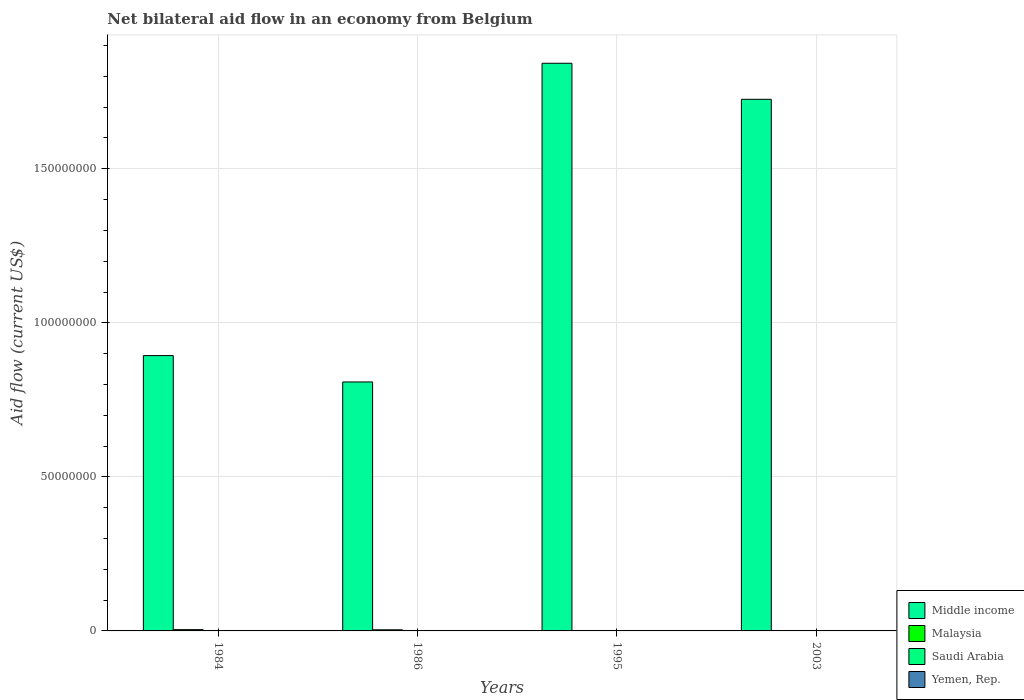Are the number of bars per tick equal to the number of legend labels?
Make the answer very short. No. Are the number of bars on each tick of the X-axis equal?
Provide a succinct answer. No. How many bars are there on the 3rd tick from the right?
Your answer should be very brief. 4. What is the label of the 3rd group of bars from the left?
Keep it short and to the point. 1995. Across all years, what is the minimum net bilateral aid flow in Middle income?
Ensure brevity in your answer.  8.08e+07. What is the total net bilateral aid flow in Saudi Arabia in the graph?
Provide a succinct answer. 7.00e+04. What is the difference between the net bilateral aid flow in Yemen, Rep. in 1984 and that in 2003?
Provide a succinct answer. -3.00e+04. What is the difference between the net bilateral aid flow in Middle income in 2003 and the net bilateral aid flow in Yemen, Rep. in 1995?
Make the answer very short. 1.73e+08. What is the average net bilateral aid flow in Saudi Arabia per year?
Your answer should be very brief. 1.75e+04. In the year 1984, what is the difference between the net bilateral aid flow in Saudi Arabia and net bilateral aid flow in Malaysia?
Offer a very short reply. -3.70e+05. In how many years, is the net bilateral aid flow in Malaysia greater than 20000000 US$?
Provide a short and direct response. 0. What is the difference between the highest and the second highest net bilateral aid flow in Saudi Arabia?
Your response must be concise. 4.00e+04. What is the difference between the highest and the lowest net bilateral aid flow in Middle income?
Ensure brevity in your answer.  1.03e+08. Is the sum of the net bilateral aid flow in Middle income in 1986 and 2003 greater than the maximum net bilateral aid flow in Yemen, Rep. across all years?
Offer a terse response. Yes. Is it the case that in every year, the sum of the net bilateral aid flow in Malaysia and net bilateral aid flow in Middle income is greater than the sum of net bilateral aid flow in Yemen, Rep. and net bilateral aid flow in Saudi Arabia?
Provide a succinct answer. Yes. How many bars are there?
Give a very brief answer. 15. Are all the bars in the graph horizontal?
Give a very brief answer. No. How many years are there in the graph?
Offer a terse response. 4. What is the difference between two consecutive major ticks on the Y-axis?
Give a very brief answer. 5.00e+07. Are the values on the major ticks of Y-axis written in scientific E-notation?
Your answer should be compact. No. Does the graph contain any zero values?
Keep it short and to the point. Yes. How many legend labels are there?
Your answer should be compact. 4. What is the title of the graph?
Your answer should be compact. Net bilateral aid flow in an economy from Belgium. What is the Aid flow (current US$) in Middle income in 1984?
Your answer should be compact. 8.94e+07. What is the Aid flow (current US$) in Malaysia in 1984?
Offer a terse response. 4.20e+05. What is the Aid flow (current US$) of Middle income in 1986?
Keep it short and to the point. 8.08e+07. What is the Aid flow (current US$) in Middle income in 1995?
Provide a short and direct response. 1.84e+08. What is the Aid flow (current US$) in Saudi Arabia in 1995?
Your response must be concise. 10000. What is the Aid flow (current US$) of Middle income in 2003?
Make the answer very short. 1.73e+08. What is the Aid flow (current US$) of Malaysia in 2003?
Give a very brief answer. 9.00e+04. What is the Aid flow (current US$) in Yemen, Rep. in 2003?
Keep it short and to the point. 1.10e+05. Across all years, what is the maximum Aid flow (current US$) in Middle income?
Give a very brief answer. 1.84e+08. Across all years, what is the maximum Aid flow (current US$) of Malaysia?
Your response must be concise. 4.20e+05. Across all years, what is the maximum Aid flow (current US$) of Saudi Arabia?
Offer a very short reply. 5.00e+04. Across all years, what is the maximum Aid flow (current US$) in Yemen, Rep.?
Offer a very short reply. 1.10e+05. Across all years, what is the minimum Aid flow (current US$) in Middle income?
Make the answer very short. 8.08e+07. Across all years, what is the minimum Aid flow (current US$) in Malaysia?
Ensure brevity in your answer.  9.00e+04. Across all years, what is the minimum Aid flow (current US$) in Saudi Arabia?
Your answer should be very brief. 0. What is the total Aid flow (current US$) of Middle income in the graph?
Give a very brief answer. 5.27e+08. What is the total Aid flow (current US$) of Malaysia in the graph?
Give a very brief answer. 9.70e+05. What is the total Aid flow (current US$) of Yemen, Rep. in the graph?
Provide a succinct answer. 2.10e+05. What is the difference between the Aid flow (current US$) of Middle income in 1984 and that in 1986?
Your answer should be very brief. 8.56e+06. What is the difference between the Aid flow (current US$) in Malaysia in 1984 and that in 1986?
Offer a terse response. 6.00e+04. What is the difference between the Aid flow (current US$) of Saudi Arabia in 1984 and that in 1986?
Your answer should be very brief. 4.00e+04. What is the difference between the Aid flow (current US$) in Yemen, Rep. in 1984 and that in 1986?
Offer a very short reply. 7.00e+04. What is the difference between the Aid flow (current US$) of Middle income in 1984 and that in 1995?
Provide a short and direct response. -9.49e+07. What is the difference between the Aid flow (current US$) in Saudi Arabia in 1984 and that in 1995?
Your response must be concise. 4.00e+04. What is the difference between the Aid flow (current US$) of Middle income in 1984 and that in 2003?
Your answer should be compact. -8.32e+07. What is the difference between the Aid flow (current US$) of Yemen, Rep. in 1984 and that in 2003?
Your response must be concise. -3.00e+04. What is the difference between the Aid flow (current US$) of Middle income in 1986 and that in 1995?
Your answer should be very brief. -1.03e+08. What is the difference between the Aid flow (current US$) of Malaysia in 1986 and that in 1995?
Keep it short and to the point. 2.60e+05. What is the difference between the Aid flow (current US$) in Saudi Arabia in 1986 and that in 1995?
Give a very brief answer. 0. What is the difference between the Aid flow (current US$) in Middle income in 1986 and that in 2003?
Make the answer very short. -9.18e+07. What is the difference between the Aid flow (current US$) of Malaysia in 1986 and that in 2003?
Offer a terse response. 2.70e+05. What is the difference between the Aid flow (current US$) of Middle income in 1995 and that in 2003?
Make the answer very short. 1.17e+07. What is the difference between the Aid flow (current US$) of Malaysia in 1995 and that in 2003?
Offer a very short reply. 10000. What is the difference between the Aid flow (current US$) of Yemen, Rep. in 1995 and that in 2003?
Provide a succinct answer. -1.00e+05. What is the difference between the Aid flow (current US$) in Middle income in 1984 and the Aid flow (current US$) in Malaysia in 1986?
Ensure brevity in your answer.  8.90e+07. What is the difference between the Aid flow (current US$) of Middle income in 1984 and the Aid flow (current US$) of Saudi Arabia in 1986?
Give a very brief answer. 8.94e+07. What is the difference between the Aid flow (current US$) of Middle income in 1984 and the Aid flow (current US$) of Yemen, Rep. in 1986?
Your answer should be very brief. 8.94e+07. What is the difference between the Aid flow (current US$) of Malaysia in 1984 and the Aid flow (current US$) of Saudi Arabia in 1986?
Give a very brief answer. 4.10e+05. What is the difference between the Aid flow (current US$) of Malaysia in 1984 and the Aid flow (current US$) of Yemen, Rep. in 1986?
Keep it short and to the point. 4.10e+05. What is the difference between the Aid flow (current US$) in Middle income in 1984 and the Aid flow (current US$) in Malaysia in 1995?
Provide a succinct answer. 8.93e+07. What is the difference between the Aid flow (current US$) in Middle income in 1984 and the Aid flow (current US$) in Saudi Arabia in 1995?
Provide a short and direct response. 8.94e+07. What is the difference between the Aid flow (current US$) in Middle income in 1984 and the Aid flow (current US$) in Yemen, Rep. in 1995?
Keep it short and to the point. 8.94e+07. What is the difference between the Aid flow (current US$) in Malaysia in 1984 and the Aid flow (current US$) in Saudi Arabia in 1995?
Your answer should be compact. 4.10e+05. What is the difference between the Aid flow (current US$) in Malaysia in 1984 and the Aid flow (current US$) in Yemen, Rep. in 1995?
Offer a terse response. 4.10e+05. What is the difference between the Aid flow (current US$) in Saudi Arabia in 1984 and the Aid flow (current US$) in Yemen, Rep. in 1995?
Offer a very short reply. 4.00e+04. What is the difference between the Aid flow (current US$) in Middle income in 1984 and the Aid flow (current US$) in Malaysia in 2003?
Ensure brevity in your answer.  8.93e+07. What is the difference between the Aid flow (current US$) of Middle income in 1984 and the Aid flow (current US$) of Yemen, Rep. in 2003?
Give a very brief answer. 8.93e+07. What is the difference between the Aid flow (current US$) of Malaysia in 1984 and the Aid flow (current US$) of Yemen, Rep. in 2003?
Ensure brevity in your answer.  3.10e+05. What is the difference between the Aid flow (current US$) of Saudi Arabia in 1984 and the Aid flow (current US$) of Yemen, Rep. in 2003?
Give a very brief answer. -6.00e+04. What is the difference between the Aid flow (current US$) of Middle income in 1986 and the Aid flow (current US$) of Malaysia in 1995?
Make the answer very short. 8.07e+07. What is the difference between the Aid flow (current US$) in Middle income in 1986 and the Aid flow (current US$) in Saudi Arabia in 1995?
Provide a short and direct response. 8.08e+07. What is the difference between the Aid flow (current US$) in Middle income in 1986 and the Aid flow (current US$) in Yemen, Rep. in 1995?
Offer a very short reply. 8.08e+07. What is the difference between the Aid flow (current US$) of Malaysia in 1986 and the Aid flow (current US$) of Saudi Arabia in 1995?
Offer a terse response. 3.50e+05. What is the difference between the Aid flow (current US$) of Malaysia in 1986 and the Aid flow (current US$) of Yemen, Rep. in 1995?
Offer a very short reply. 3.50e+05. What is the difference between the Aid flow (current US$) in Saudi Arabia in 1986 and the Aid flow (current US$) in Yemen, Rep. in 1995?
Offer a very short reply. 0. What is the difference between the Aid flow (current US$) of Middle income in 1986 and the Aid flow (current US$) of Malaysia in 2003?
Provide a short and direct response. 8.07e+07. What is the difference between the Aid flow (current US$) in Middle income in 1986 and the Aid flow (current US$) in Yemen, Rep. in 2003?
Offer a terse response. 8.07e+07. What is the difference between the Aid flow (current US$) in Malaysia in 1986 and the Aid flow (current US$) in Yemen, Rep. in 2003?
Keep it short and to the point. 2.50e+05. What is the difference between the Aid flow (current US$) in Saudi Arabia in 1986 and the Aid flow (current US$) in Yemen, Rep. in 2003?
Make the answer very short. -1.00e+05. What is the difference between the Aid flow (current US$) in Middle income in 1995 and the Aid flow (current US$) in Malaysia in 2003?
Your answer should be very brief. 1.84e+08. What is the difference between the Aid flow (current US$) of Middle income in 1995 and the Aid flow (current US$) of Yemen, Rep. in 2003?
Ensure brevity in your answer.  1.84e+08. What is the difference between the Aid flow (current US$) in Malaysia in 1995 and the Aid flow (current US$) in Yemen, Rep. in 2003?
Keep it short and to the point. -10000. What is the difference between the Aid flow (current US$) in Saudi Arabia in 1995 and the Aid flow (current US$) in Yemen, Rep. in 2003?
Your response must be concise. -1.00e+05. What is the average Aid flow (current US$) of Middle income per year?
Your response must be concise. 1.32e+08. What is the average Aid flow (current US$) in Malaysia per year?
Your answer should be very brief. 2.42e+05. What is the average Aid flow (current US$) of Saudi Arabia per year?
Ensure brevity in your answer.  1.75e+04. What is the average Aid flow (current US$) of Yemen, Rep. per year?
Make the answer very short. 5.25e+04. In the year 1984, what is the difference between the Aid flow (current US$) in Middle income and Aid flow (current US$) in Malaysia?
Provide a short and direct response. 8.90e+07. In the year 1984, what is the difference between the Aid flow (current US$) in Middle income and Aid flow (current US$) in Saudi Arabia?
Offer a very short reply. 8.93e+07. In the year 1984, what is the difference between the Aid flow (current US$) in Middle income and Aid flow (current US$) in Yemen, Rep.?
Make the answer very short. 8.93e+07. In the year 1984, what is the difference between the Aid flow (current US$) of Malaysia and Aid flow (current US$) of Saudi Arabia?
Give a very brief answer. 3.70e+05. In the year 1986, what is the difference between the Aid flow (current US$) of Middle income and Aid flow (current US$) of Malaysia?
Ensure brevity in your answer.  8.04e+07. In the year 1986, what is the difference between the Aid flow (current US$) of Middle income and Aid flow (current US$) of Saudi Arabia?
Keep it short and to the point. 8.08e+07. In the year 1986, what is the difference between the Aid flow (current US$) in Middle income and Aid flow (current US$) in Yemen, Rep.?
Your answer should be very brief. 8.08e+07. In the year 1986, what is the difference between the Aid flow (current US$) of Malaysia and Aid flow (current US$) of Saudi Arabia?
Provide a short and direct response. 3.50e+05. In the year 1986, what is the difference between the Aid flow (current US$) in Saudi Arabia and Aid flow (current US$) in Yemen, Rep.?
Your response must be concise. 0. In the year 1995, what is the difference between the Aid flow (current US$) of Middle income and Aid flow (current US$) of Malaysia?
Your answer should be compact. 1.84e+08. In the year 1995, what is the difference between the Aid flow (current US$) of Middle income and Aid flow (current US$) of Saudi Arabia?
Make the answer very short. 1.84e+08. In the year 1995, what is the difference between the Aid flow (current US$) of Middle income and Aid flow (current US$) of Yemen, Rep.?
Offer a terse response. 1.84e+08. In the year 1995, what is the difference between the Aid flow (current US$) of Malaysia and Aid flow (current US$) of Saudi Arabia?
Give a very brief answer. 9.00e+04. In the year 1995, what is the difference between the Aid flow (current US$) in Malaysia and Aid flow (current US$) in Yemen, Rep.?
Your answer should be very brief. 9.00e+04. In the year 2003, what is the difference between the Aid flow (current US$) in Middle income and Aid flow (current US$) in Malaysia?
Offer a terse response. 1.72e+08. In the year 2003, what is the difference between the Aid flow (current US$) of Middle income and Aid flow (current US$) of Yemen, Rep.?
Give a very brief answer. 1.72e+08. In the year 2003, what is the difference between the Aid flow (current US$) in Malaysia and Aid flow (current US$) in Yemen, Rep.?
Your answer should be compact. -2.00e+04. What is the ratio of the Aid flow (current US$) of Middle income in 1984 to that in 1986?
Ensure brevity in your answer.  1.11. What is the ratio of the Aid flow (current US$) of Middle income in 1984 to that in 1995?
Provide a short and direct response. 0.48. What is the ratio of the Aid flow (current US$) of Malaysia in 1984 to that in 1995?
Provide a short and direct response. 4.2. What is the ratio of the Aid flow (current US$) in Middle income in 1984 to that in 2003?
Provide a succinct answer. 0.52. What is the ratio of the Aid flow (current US$) of Malaysia in 1984 to that in 2003?
Offer a very short reply. 4.67. What is the ratio of the Aid flow (current US$) of Yemen, Rep. in 1984 to that in 2003?
Offer a very short reply. 0.73. What is the ratio of the Aid flow (current US$) of Middle income in 1986 to that in 1995?
Make the answer very short. 0.44. What is the ratio of the Aid flow (current US$) of Malaysia in 1986 to that in 1995?
Keep it short and to the point. 3.6. What is the ratio of the Aid flow (current US$) in Middle income in 1986 to that in 2003?
Provide a succinct answer. 0.47. What is the ratio of the Aid flow (current US$) of Malaysia in 1986 to that in 2003?
Keep it short and to the point. 4. What is the ratio of the Aid flow (current US$) of Yemen, Rep. in 1986 to that in 2003?
Offer a very short reply. 0.09. What is the ratio of the Aid flow (current US$) of Middle income in 1995 to that in 2003?
Give a very brief answer. 1.07. What is the ratio of the Aid flow (current US$) of Yemen, Rep. in 1995 to that in 2003?
Provide a succinct answer. 0.09. What is the difference between the highest and the second highest Aid flow (current US$) in Middle income?
Give a very brief answer. 1.17e+07. What is the difference between the highest and the second highest Aid flow (current US$) in Malaysia?
Offer a terse response. 6.00e+04. What is the difference between the highest and the lowest Aid flow (current US$) of Middle income?
Provide a short and direct response. 1.03e+08. What is the difference between the highest and the lowest Aid flow (current US$) in Malaysia?
Your answer should be very brief. 3.30e+05. What is the difference between the highest and the lowest Aid flow (current US$) of Saudi Arabia?
Give a very brief answer. 5.00e+04. 